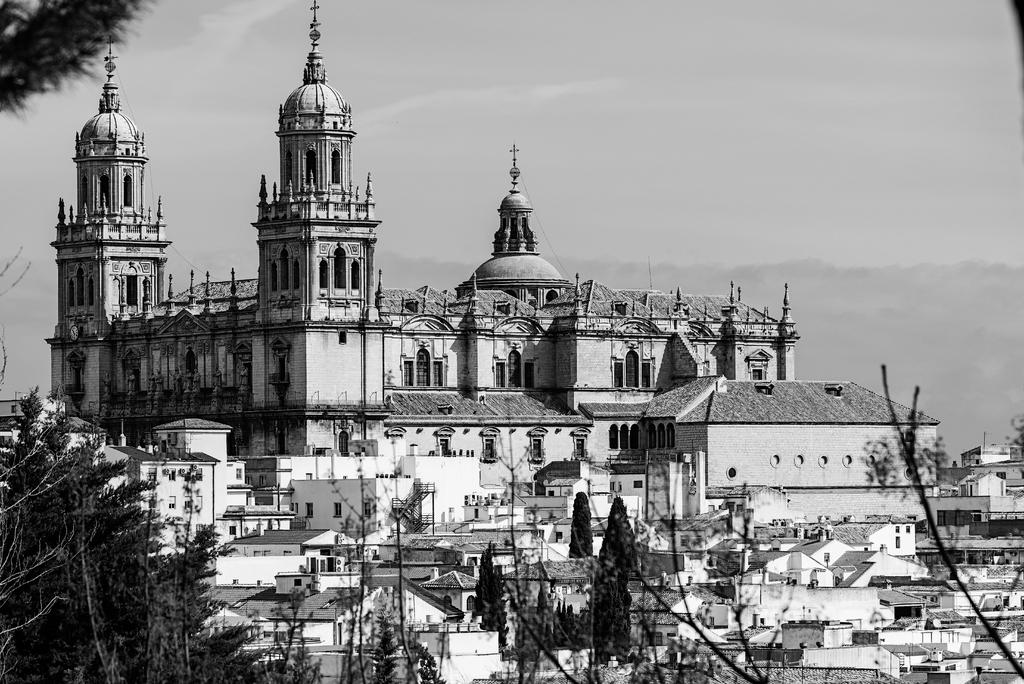What type of picture is in the image? The image contains a black and white picture. What is shown in the picture? The picture depicts buildings and trees. Can you describe the landscape in the image? There is a hill visible in the image. What part of the natural environment is visible in the image? The sky is visible in the image. What is the weight of the jelly in the image? There is no jelly present in the image, so it is not possible to determine its weight. 